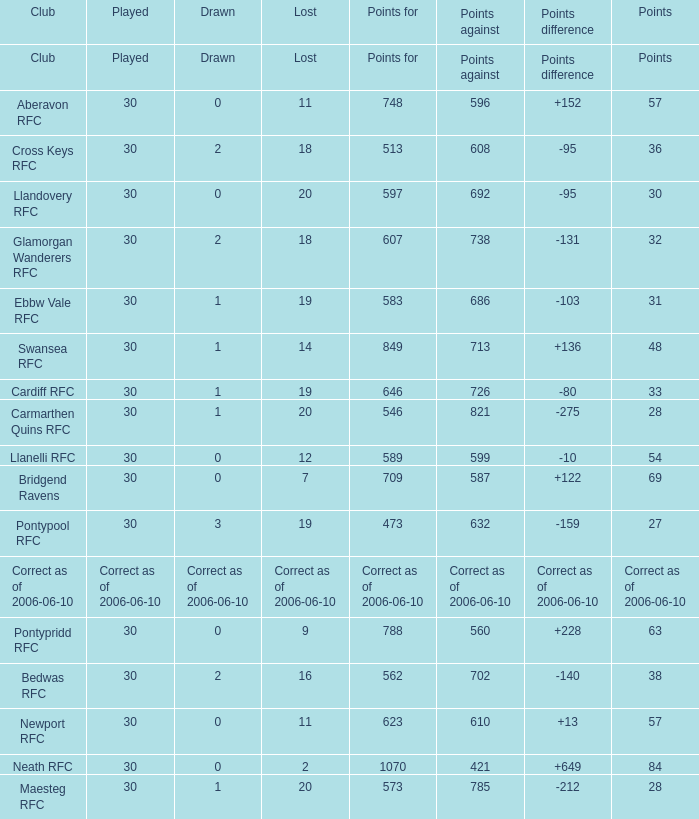What is Drawn, when Played is "Correct as of 2006-06-10"? Correct as of 2006-06-10. 